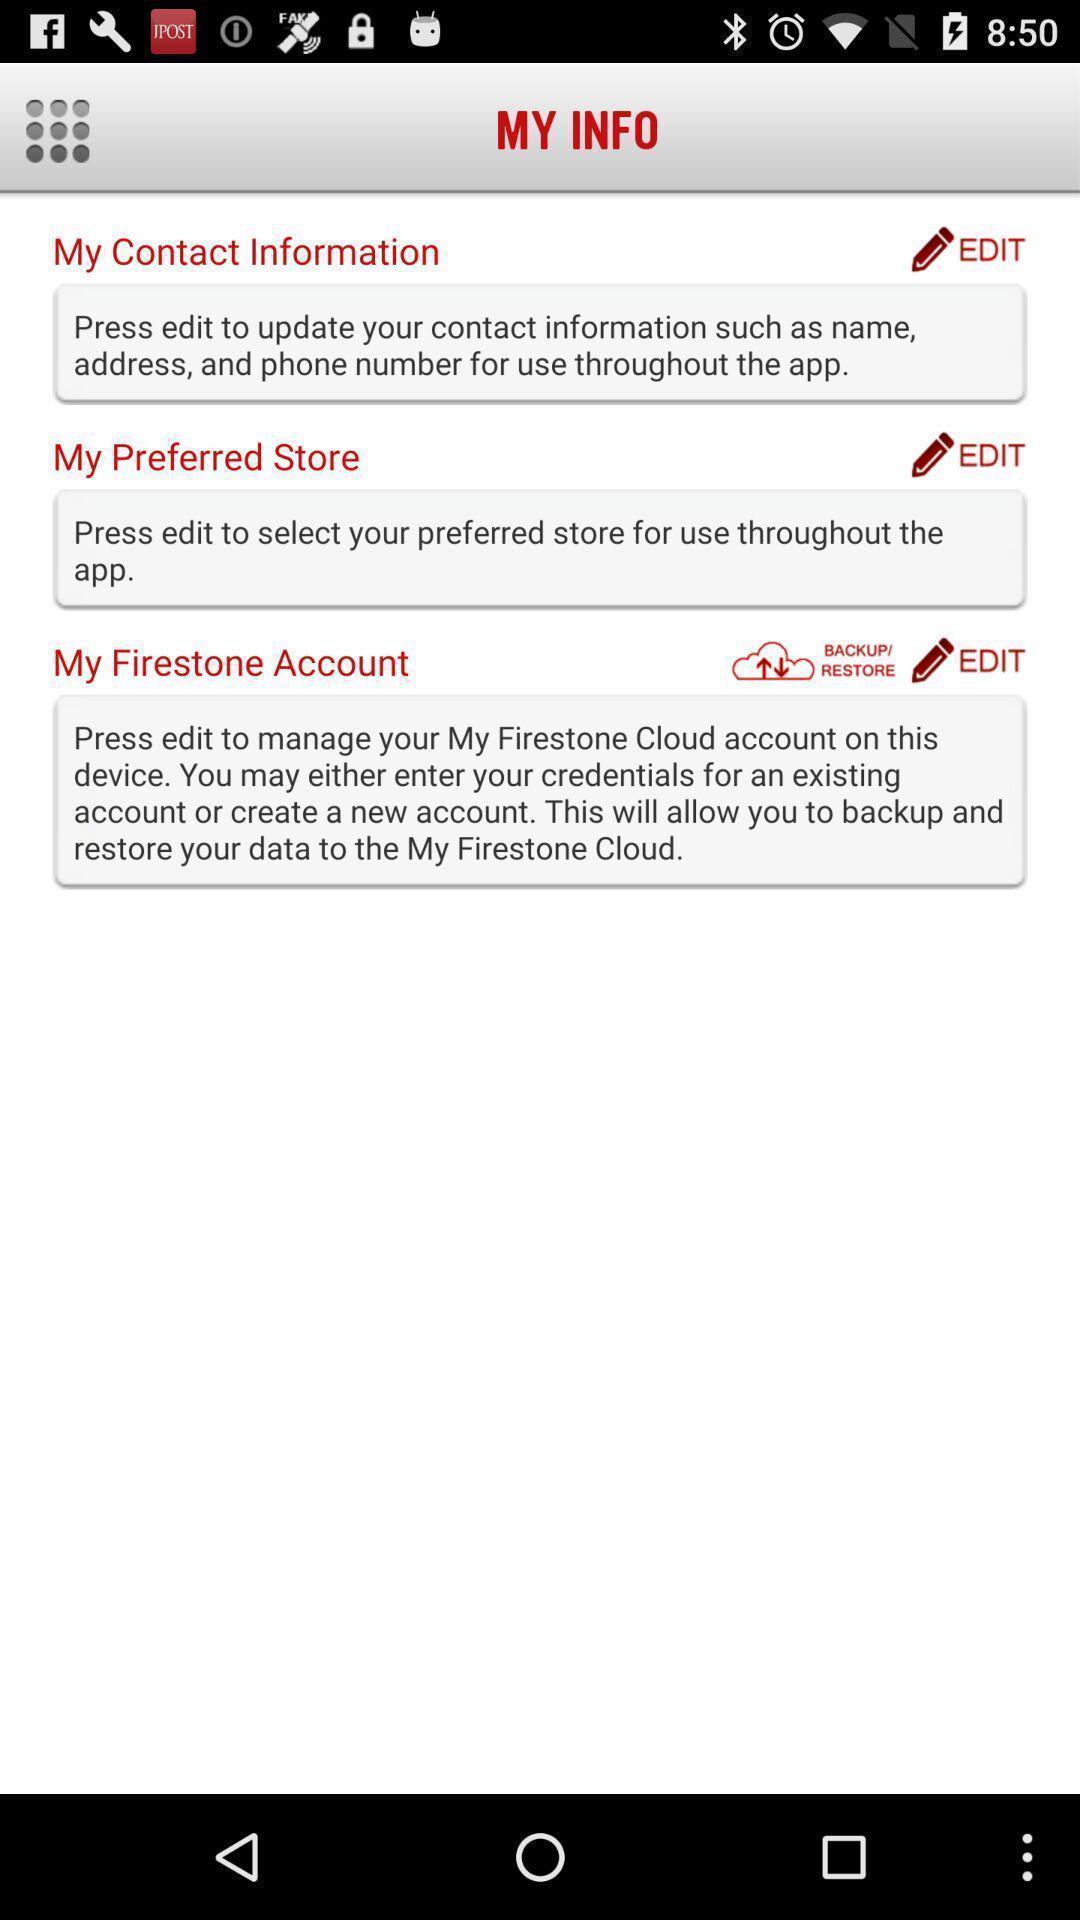Describe the visual elements of this screenshot. Profile information page. 